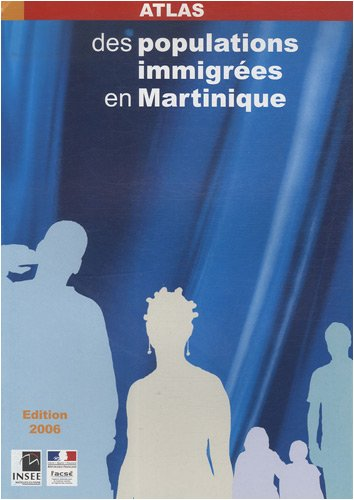Is this book related to Travel? Although it may include maps and geographic information about Martinique, the main purpose of this atlas is to provide detailed demographic data on immigrant populations, which does not directly align with traditional travel-related content. 